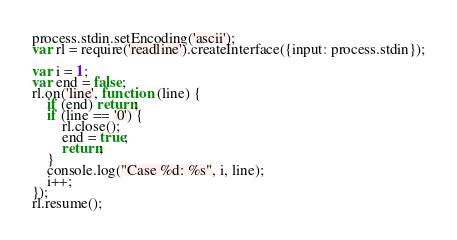Convert code to text. <code><loc_0><loc_0><loc_500><loc_500><_JavaScript_>process.stdin.setEncoding('ascii');
var rl = require('readline').createInterface({input: process.stdin});

var i = 1;
var end = false;
rl.on('line', function (line) {
	if (end) return;
	if (line == '0') {
		rl.close();
		end = true;
		return;
	}
	console.log("Case %d: %s", i, line);
	i++;
});
rl.resume();</code> 